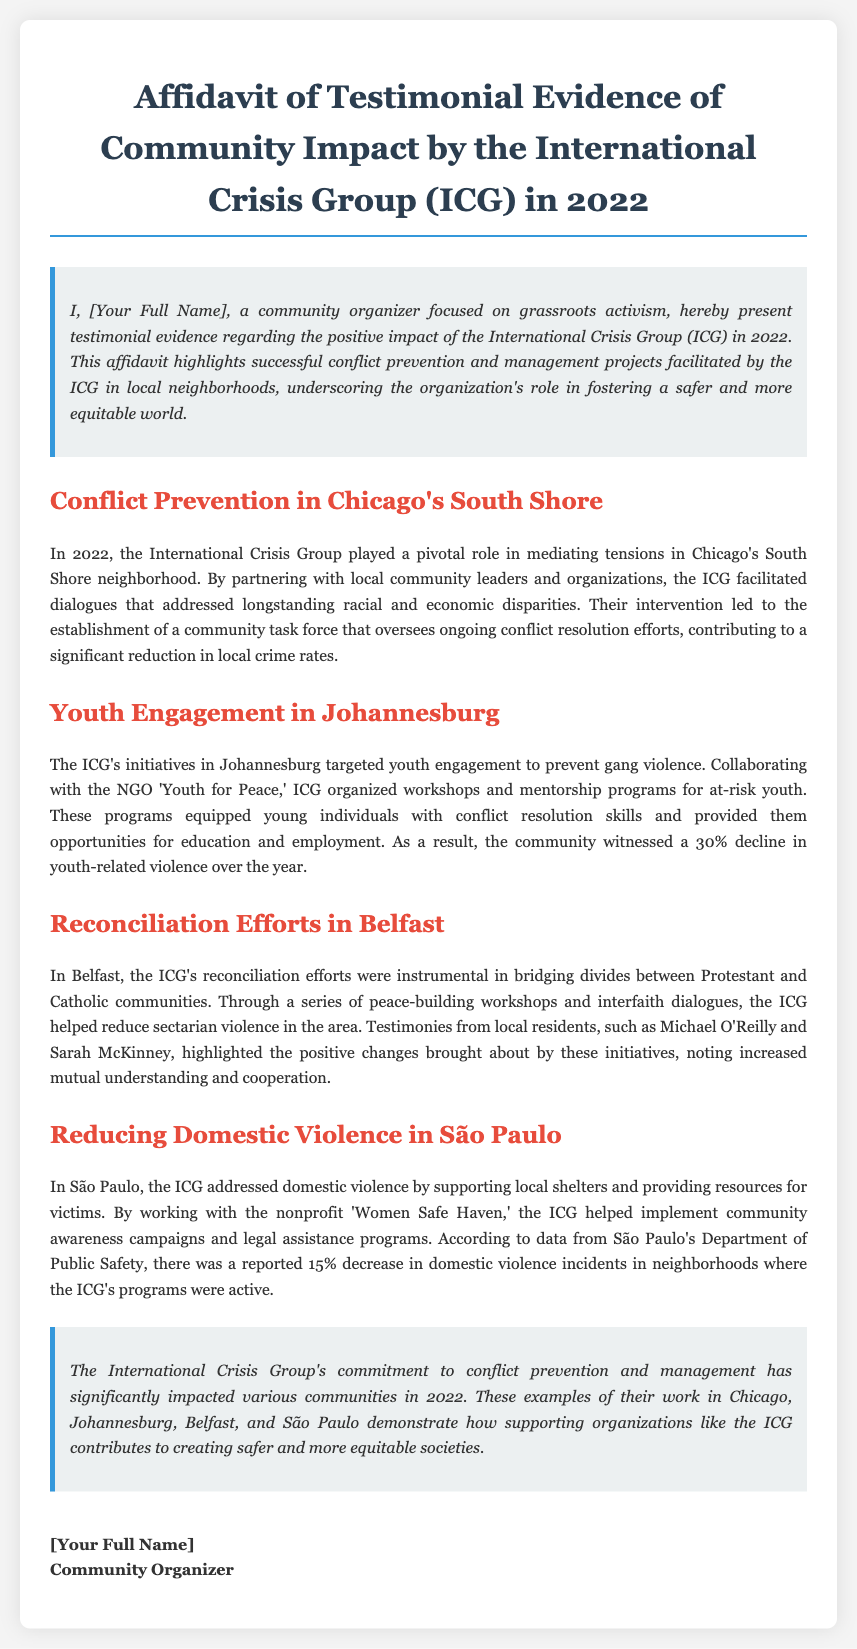what year is the focus of the affidavit? The affidavit highlights the impact of the ICG in the year 2022.
Answer: 2022 which neighborhood did the ICG work in Chicago? The ICG worked in the South Shore neighborhood of Chicago.
Answer: South Shore what percentage decline in youth-related violence was reported in Johannesburg? The community witnessed a 30% decline in youth-related violence over the year due to ICG initiatives.
Answer: 30% who were the local residents providing testimonies in Belfast? Michael O'Reilly and Sarah McKinney provided testimonies about the ICG's initiatives in Belfast.
Answer: Michael O'Reilly and Sarah McKinney what was the reported decrease in domestic violence incidents in São Paulo? There was a reported 15% decrease in domestic violence incidents in neighborhoods where the ICG's programs were active.
Answer: 15% what type of programs did ICG organize for at-risk youth in Johannesburg? The ICG organized workshops and mentorship programs for at-risk youth.
Answer: workshops and mentorship programs what type of violence did the ICG address in São Paulo? The ICG addressed domestic violence in São Paulo.
Answer: domestic violence what was established after ICG's intervention in South Shore? A community task force was established to oversee ongoing conflict resolution efforts in South Shore.
Answer: community task force what is the primary goal of the International Crisis Group according to the affidavit? The primary goal of the ICG is conflict prevention and management.
Answer: conflict prevention and management 